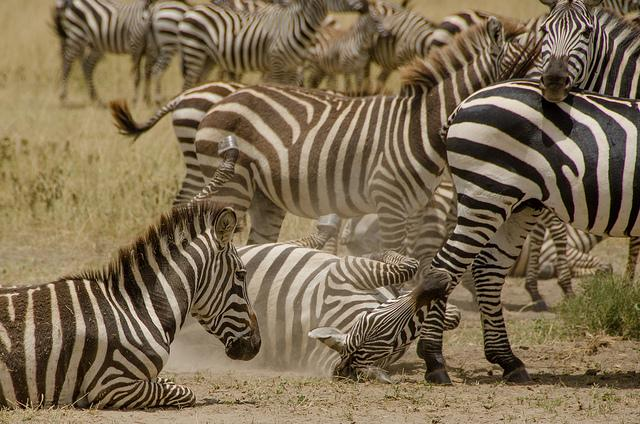How would these animals be classified? Please explain your reasoning. herbivores. They eat grass. 